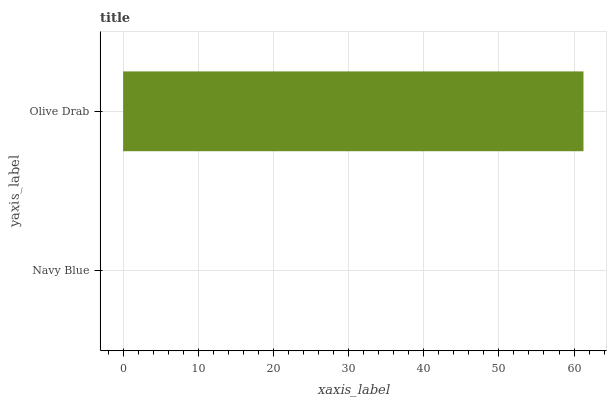Is Navy Blue the minimum?
Answer yes or no. Yes. Is Olive Drab the maximum?
Answer yes or no. Yes. Is Olive Drab the minimum?
Answer yes or no. No. Is Olive Drab greater than Navy Blue?
Answer yes or no. Yes. Is Navy Blue less than Olive Drab?
Answer yes or no. Yes. Is Navy Blue greater than Olive Drab?
Answer yes or no. No. Is Olive Drab less than Navy Blue?
Answer yes or no. No. Is Olive Drab the high median?
Answer yes or no. Yes. Is Navy Blue the low median?
Answer yes or no. Yes. Is Navy Blue the high median?
Answer yes or no. No. Is Olive Drab the low median?
Answer yes or no. No. 